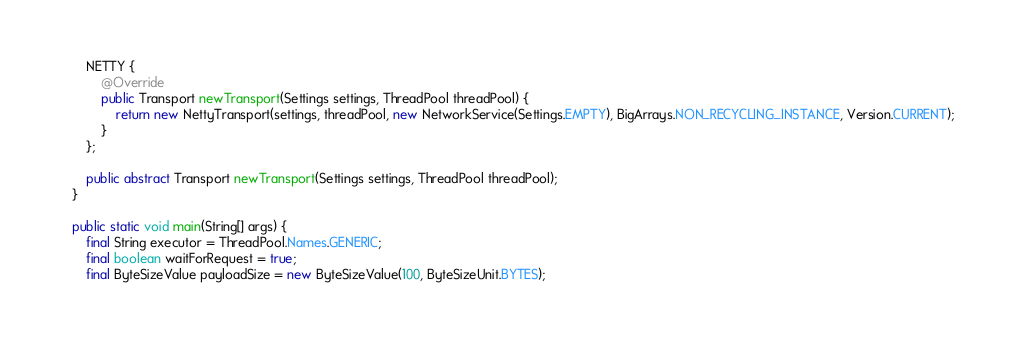Convert code to text. <code><loc_0><loc_0><loc_500><loc_500><_Java_>        NETTY {
            @Override
            public Transport newTransport(Settings settings, ThreadPool threadPool) {
                return new NettyTransport(settings, threadPool, new NetworkService(Settings.EMPTY), BigArrays.NON_RECYCLING_INSTANCE, Version.CURRENT);
            }
        };

        public abstract Transport newTransport(Settings settings, ThreadPool threadPool);
    }

    public static void main(String[] args) {
        final String executor = ThreadPool.Names.GENERIC;
        final boolean waitForRequest = true;
        final ByteSizeValue payloadSize = new ByteSizeValue(100, ByteSizeUnit.BYTES);</code> 